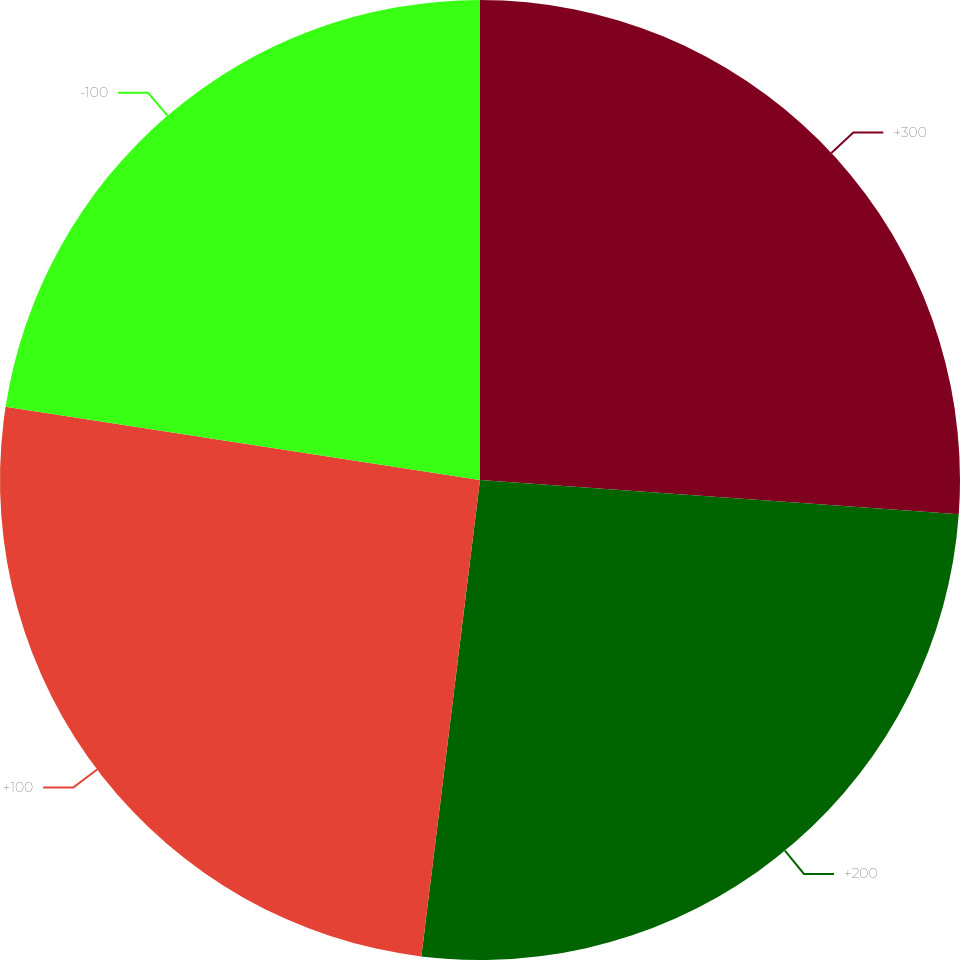<chart> <loc_0><loc_0><loc_500><loc_500><pie_chart><fcel>+300<fcel>+200<fcel>+100<fcel>-100<nl><fcel>26.14%<fcel>25.81%<fcel>25.49%<fcel>22.56%<nl></chart> 